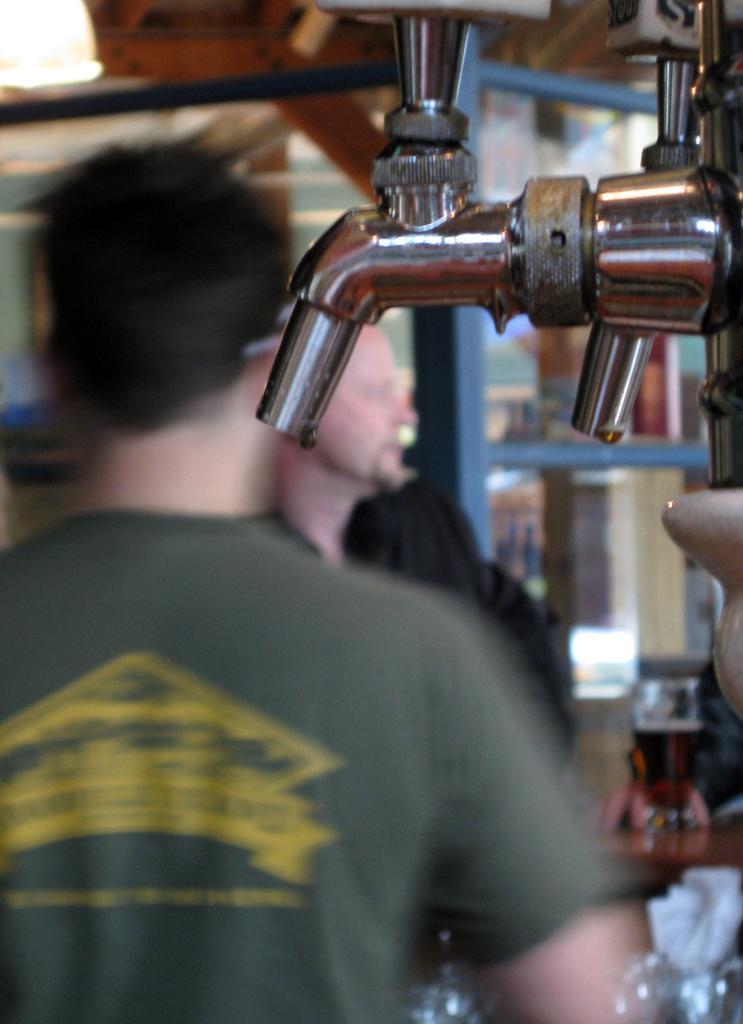Can you describe this image briefly? In this picture I can see a brewing machine and couple of them are standing. 